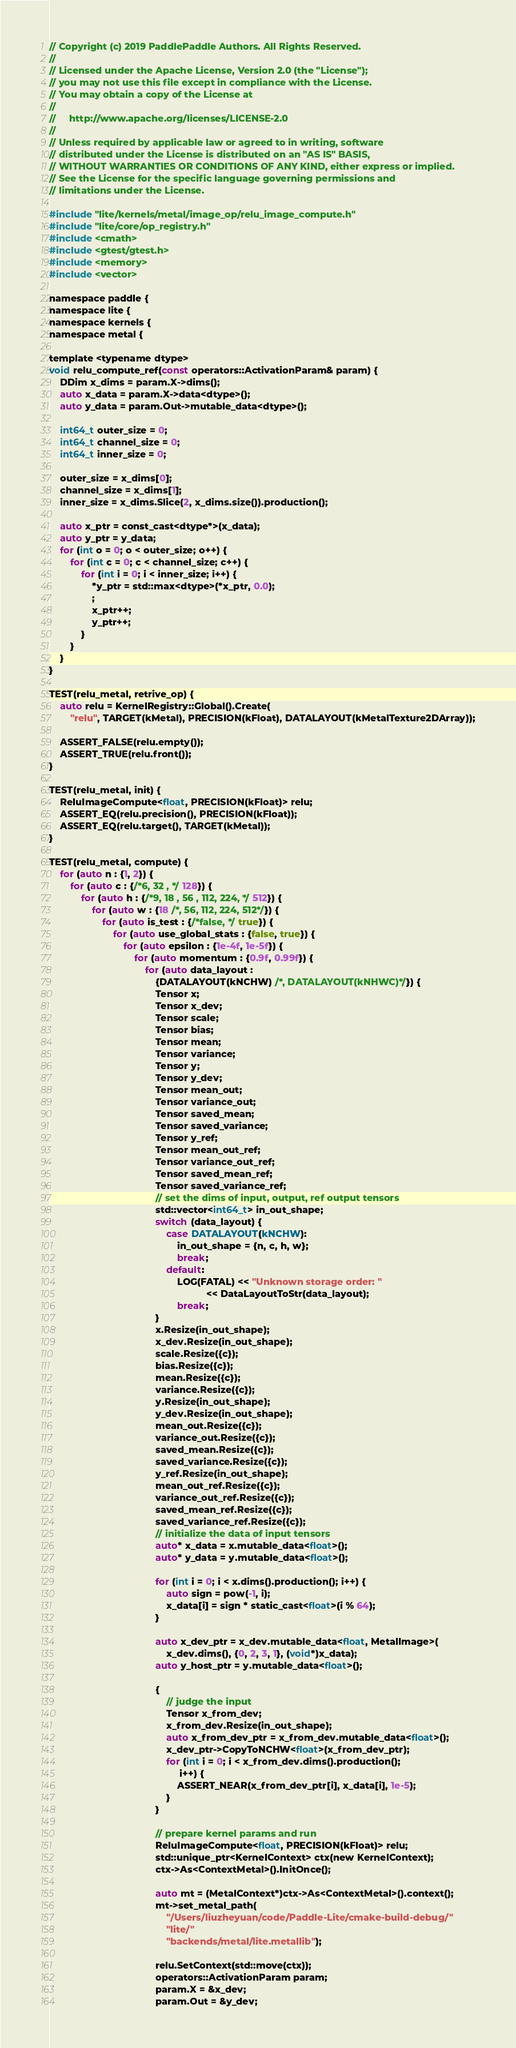<code> <loc_0><loc_0><loc_500><loc_500><_ObjectiveC_>// Copyright (c) 2019 PaddlePaddle Authors. All Rights Reserved.
//
// Licensed under the Apache License, Version 2.0 (the "License");
// you may not use this file except in compliance with the License.
// You may obtain a copy of the License at
//
//     http://www.apache.org/licenses/LICENSE-2.0
//
// Unless required by applicable law or agreed to in writing, software
// distributed under the License is distributed on an "AS IS" BASIS,
// WITHOUT WARRANTIES OR CONDITIONS OF ANY KIND, either express or implied.
// See the License for the specific language governing permissions and
// limitations under the License.

#include "lite/kernels/metal/image_op/relu_image_compute.h"
#include "lite/core/op_registry.h"
#include <cmath>
#include <gtest/gtest.h>
#include <memory>
#include <vector>

namespace paddle {
namespace lite {
namespace kernels {
namespace metal {

template <typename dtype>
void relu_compute_ref(const operators::ActivationParam& param) {
    DDim x_dims = param.X->dims();
    auto x_data = param.X->data<dtype>();
    auto y_data = param.Out->mutable_data<dtype>();

    int64_t outer_size = 0;
    int64_t channel_size = 0;
    int64_t inner_size = 0;

    outer_size = x_dims[0];
    channel_size = x_dims[1];
    inner_size = x_dims.Slice(2, x_dims.size()).production();

    auto x_ptr = const_cast<dtype*>(x_data);
    auto y_ptr = y_data;
    for (int o = 0; o < outer_size; o++) {
        for (int c = 0; c < channel_size; c++) {
            for (int i = 0; i < inner_size; i++) {
                *y_ptr = std::max<dtype>(*x_ptr, 0.0);
                ;
                x_ptr++;
                y_ptr++;
            }
        }
    }
}

TEST(relu_metal, retrive_op) {
    auto relu = KernelRegistry::Global().Create(
        "relu", TARGET(kMetal), PRECISION(kFloat), DATALAYOUT(kMetalTexture2DArray));

    ASSERT_FALSE(relu.empty());
    ASSERT_TRUE(relu.front());
}

TEST(relu_metal, init) {
    ReluImageCompute<float, PRECISION(kFloat)> relu;
    ASSERT_EQ(relu.precision(), PRECISION(kFloat));
    ASSERT_EQ(relu.target(), TARGET(kMetal));
}

TEST(relu_metal, compute) {
    for (auto n : {1, 2}) {
        for (auto c : {/*6, 32 , */ 128}) {
            for (auto h : {/*9, 18 , 56 , 112, 224, */ 512}) {
                for (auto w : {18 /*, 56, 112, 224, 512*/}) {
                    for (auto is_test : {/*false, */ true}) {
                        for (auto use_global_stats : {false, true}) {
                            for (auto epsilon : {1e-4f, 1e-5f}) {
                                for (auto momentum : {0.9f, 0.99f}) {
                                    for (auto data_layout :
                                        {DATALAYOUT(kNCHW) /*, DATALAYOUT(kNHWC)*/}) {
                                        Tensor x;
                                        Tensor x_dev;
                                        Tensor scale;
                                        Tensor bias;
                                        Tensor mean;
                                        Tensor variance;
                                        Tensor y;
                                        Tensor y_dev;
                                        Tensor mean_out;
                                        Tensor variance_out;
                                        Tensor saved_mean;
                                        Tensor saved_variance;
                                        Tensor y_ref;
                                        Tensor mean_out_ref;
                                        Tensor variance_out_ref;
                                        Tensor saved_mean_ref;
                                        Tensor saved_variance_ref;
                                        // set the dims of input, output, ref output tensors
                                        std::vector<int64_t> in_out_shape;
                                        switch (data_layout) {
                                            case DATALAYOUT(kNCHW):
                                                in_out_shape = {n, c, h, w};
                                                break;
                                            default:
                                                LOG(FATAL) << "Unknown storage order: "
                                                           << DataLayoutToStr(data_layout);
                                                break;
                                        }
                                        x.Resize(in_out_shape);
                                        x_dev.Resize(in_out_shape);
                                        scale.Resize({c});
                                        bias.Resize({c});
                                        mean.Resize({c});
                                        variance.Resize({c});
                                        y.Resize(in_out_shape);
                                        y_dev.Resize(in_out_shape);
                                        mean_out.Resize({c});
                                        variance_out.Resize({c});
                                        saved_mean.Resize({c});
                                        saved_variance.Resize({c});
                                        y_ref.Resize(in_out_shape);
                                        mean_out_ref.Resize({c});
                                        variance_out_ref.Resize({c});
                                        saved_mean_ref.Resize({c});
                                        saved_variance_ref.Resize({c});
                                        // initialize the data of input tensors
                                        auto* x_data = x.mutable_data<float>();
                                        auto* y_data = y.mutable_data<float>();

                                        for (int i = 0; i < x.dims().production(); i++) {
                                            auto sign = pow(-1, i);
                                            x_data[i] = sign * static_cast<float>(i % 64);
                                        }

                                        auto x_dev_ptr = x_dev.mutable_data<float, MetalImage>(
                                            x_dev.dims(), {0, 2, 3, 1}, (void*)x_data);
                                        auto y_host_ptr = y.mutable_data<float>();

                                        {
                                            // judge the input
                                            Tensor x_from_dev;
                                            x_from_dev.Resize(in_out_shape);
                                            auto x_from_dev_ptr = x_from_dev.mutable_data<float>();
                                            x_dev_ptr->CopyToNCHW<float>(x_from_dev_ptr);
                                            for (int i = 0; i < x_from_dev.dims().production();
                                                 i++) {
                                                ASSERT_NEAR(x_from_dev_ptr[i], x_data[i], 1e-5);
                                            }
                                        }

                                        // prepare kernel params and run
                                        ReluImageCompute<float, PRECISION(kFloat)> relu;
                                        std::unique_ptr<KernelContext> ctx(new KernelContext);
                                        ctx->As<ContextMetal>().InitOnce();

                                        auto mt = (MetalContext*)ctx->As<ContextMetal>().context();
                                        mt->set_metal_path(
                                            "/Users/liuzheyuan/code/Paddle-Lite/cmake-build-debug/"
                                            "lite/"
                                            "backends/metal/lite.metallib");

                                        relu.SetContext(std::move(ctx));
                                        operators::ActivationParam param;
                                        param.X = &x_dev;
                                        param.Out = &y_dev;</code> 